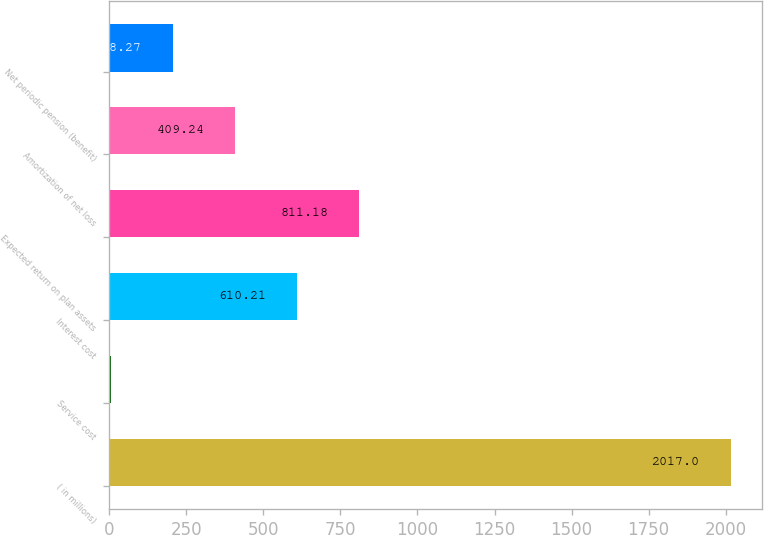<chart> <loc_0><loc_0><loc_500><loc_500><bar_chart><fcel>( in millions)<fcel>Service cost<fcel>Interest cost<fcel>Expected return on plan assets<fcel>Amortization of net loss<fcel>Net periodic pension (benefit)<nl><fcel>2017<fcel>7.3<fcel>610.21<fcel>811.18<fcel>409.24<fcel>208.27<nl></chart> 